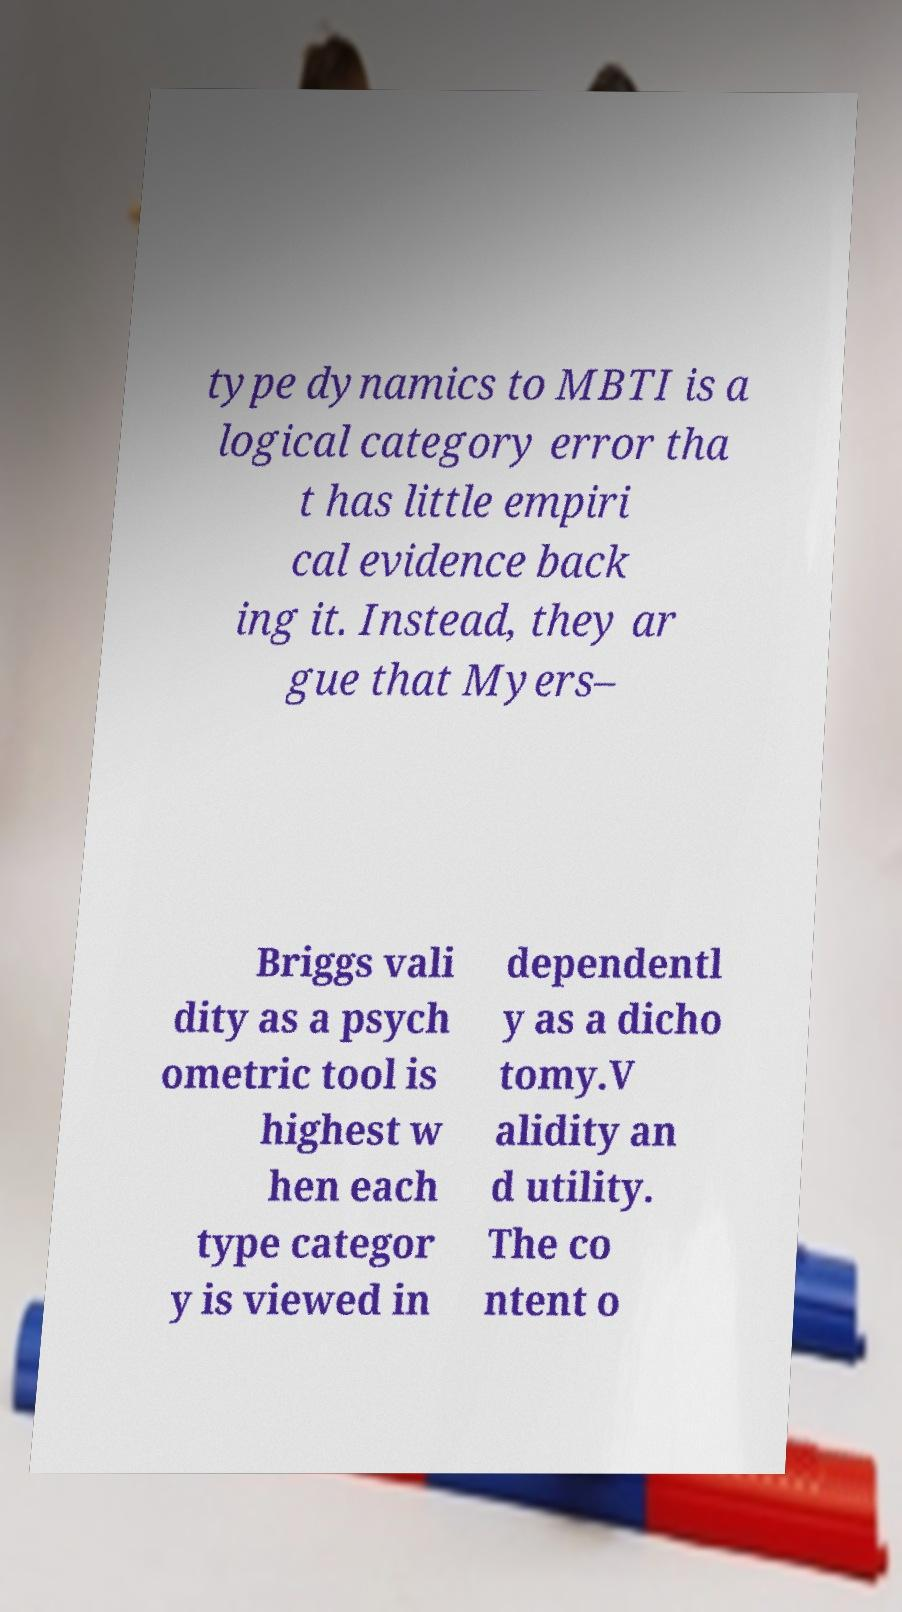There's text embedded in this image that I need extracted. Can you transcribe it verbatim? type dynamics to MBTI is a logical category error tha t has little empiri cal evidence back ing it. Instead, they ar gue that Myers– Briggs vali dity as a psych ometric tool is highest w hen each type categor y is viewed in dependentl y as a dicho tomy.V alidity an d utility. The co ntent o 